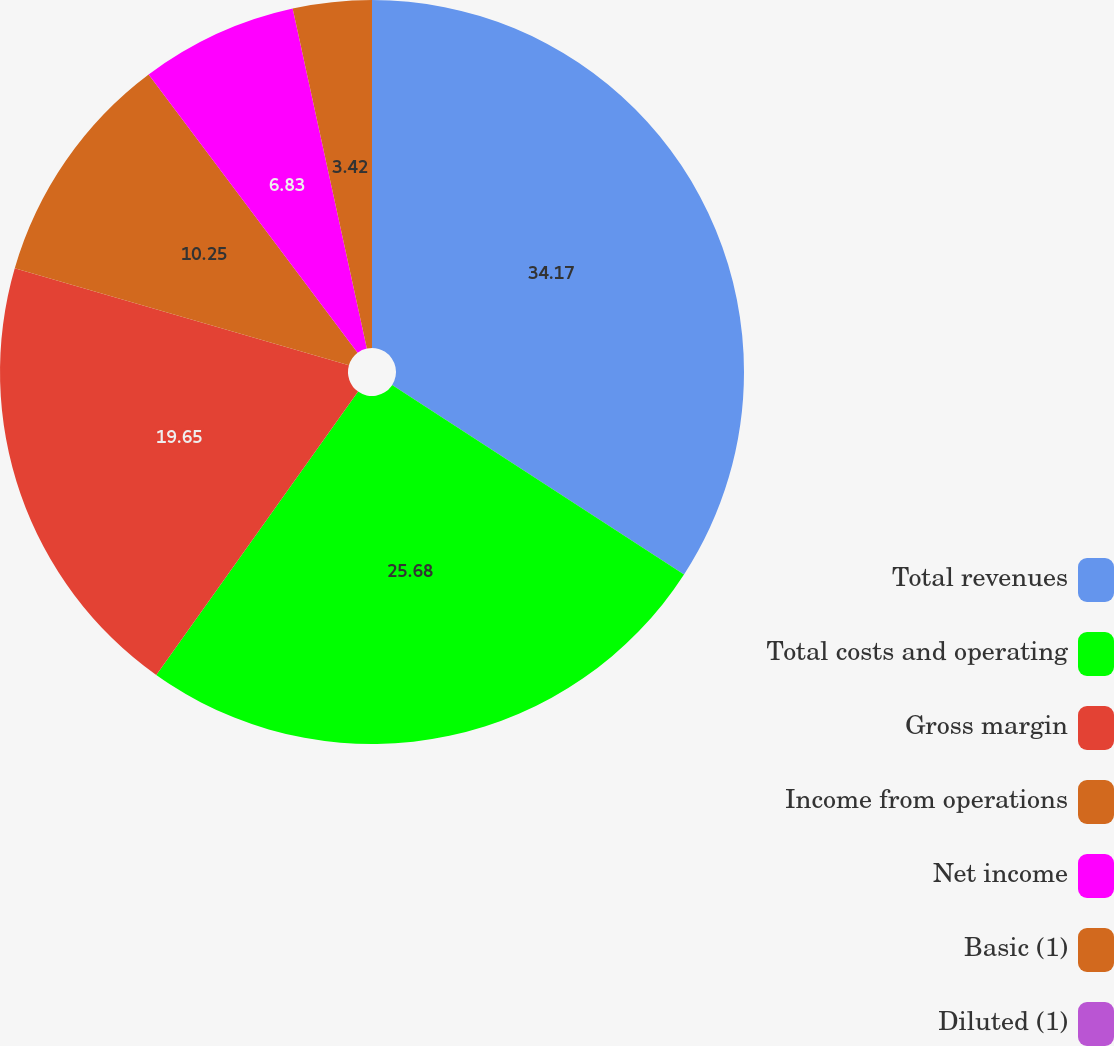Convert chart to OTSL. <chart><loc_0><loc_0><loc_500><loc_500><pie_chart><fcel>Total revenues<fcel>Total costs and operating<fcel>Gross margin<fcel>Income from operations<fcel>Net income<fcel>Basic (1)<fcel>Diluted (1)<nl><fcel>34.16%<fcel>25.68%<fcel>19.65%<fcel>10.25%<fcel>6.83%<fcel>3.42%<fcel>0.0%<nl></chart> 